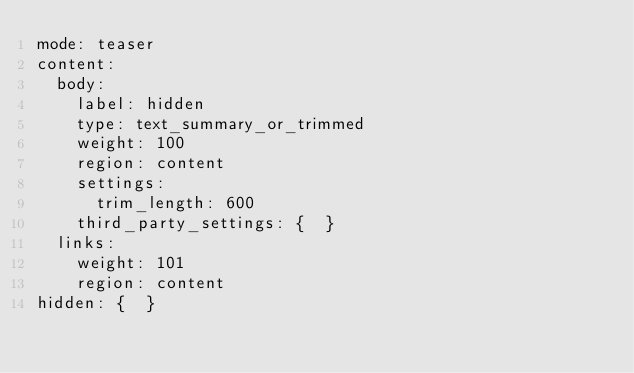<code> <loc_0><loc_0><loc_500><loc_500><_YAML_>mode: teaser
content:
  body:
    label: hidden
    type: text_summary_or_trimmed
    weight: 100
    region: content
    settings:
      trim_length: 600
    third_party_settings: {  }
  links:
    weight: 101
    region: content
hidden: {  }
</code> 